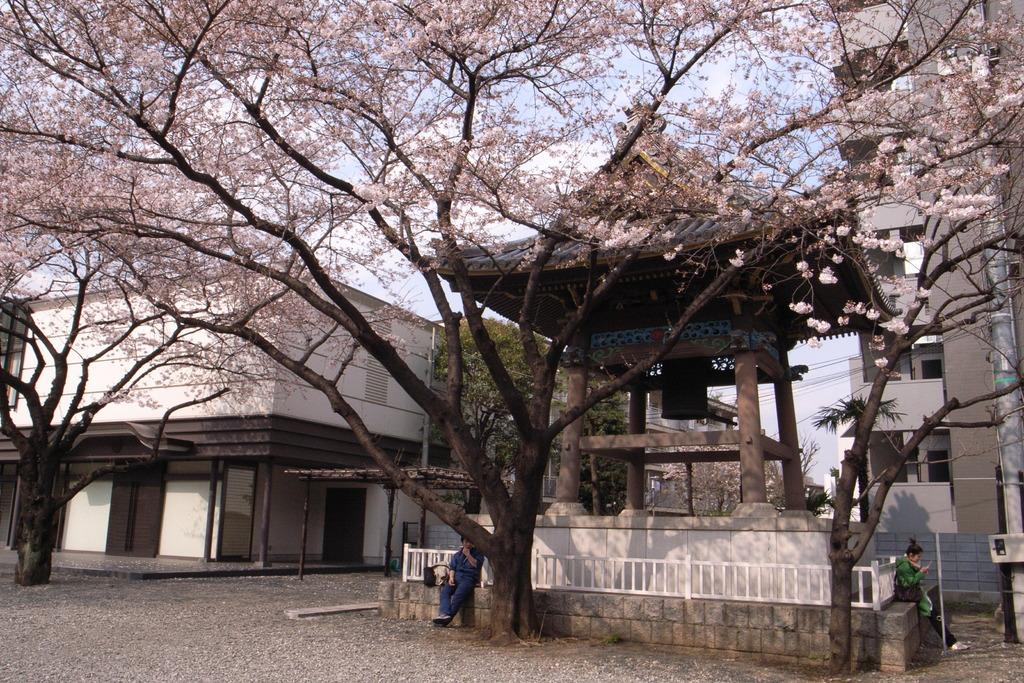How many people are sitting in the image? There are two people sitting in the image. What can be seen in the background of the image? There are buildings, trees, cables, and the sky visible in the background of the image. What type of pump is being used by the people in the image? There is no pump present in the image; it features two people sitting and the background elements mentioned earlier. 